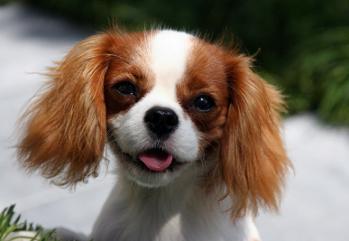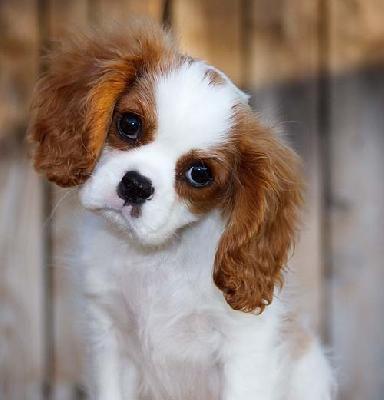The first image is the image on the left, the second image is the image on the right. Examine the images to the left and right. Is the description "ther is at least one dog on a stone surface with greenery in the background" accurate? Answer yes or no. No. 